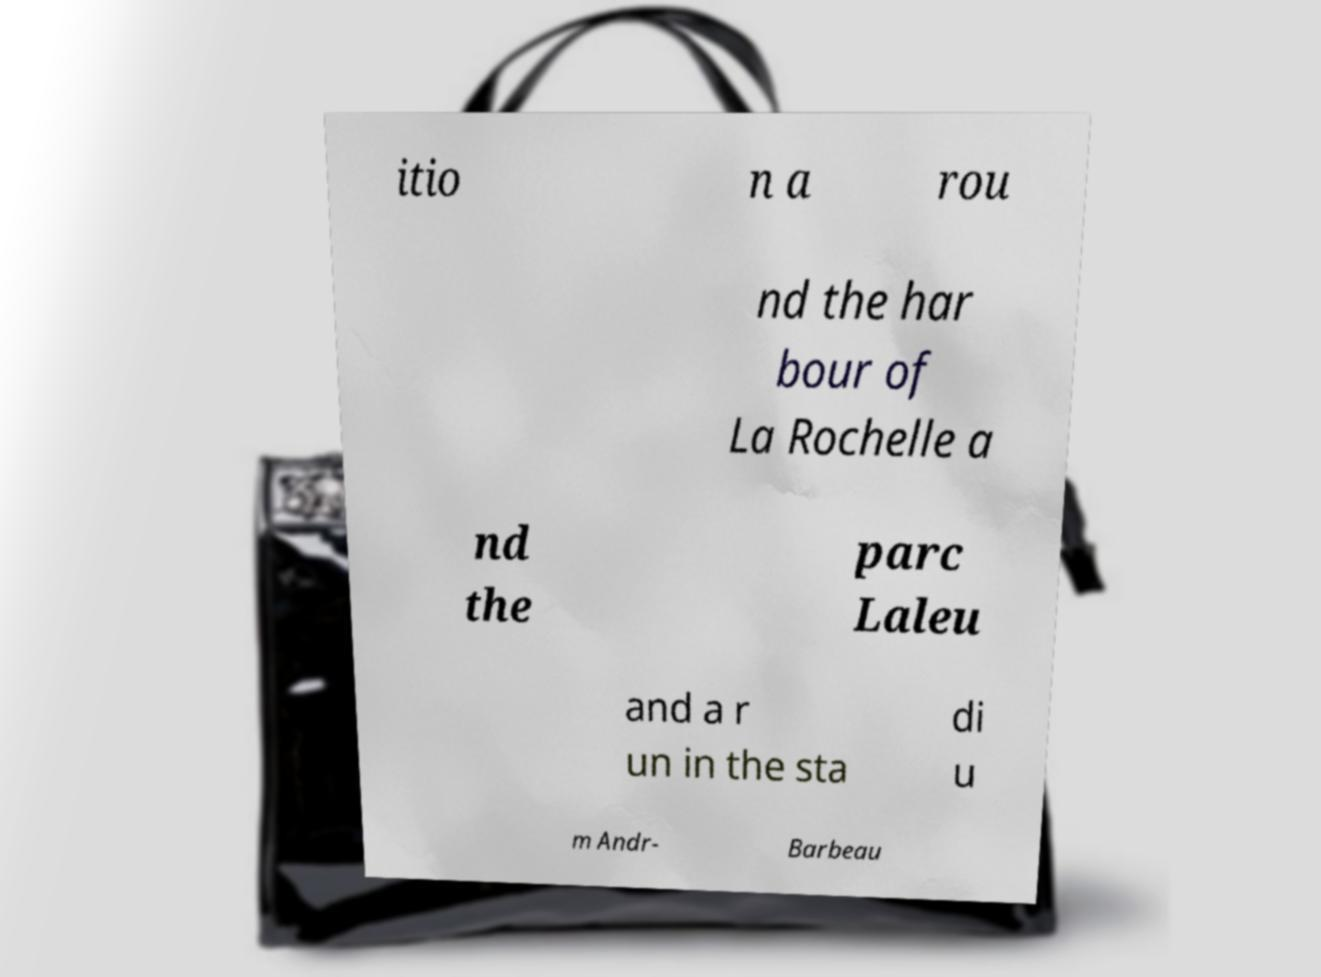Please identify and transcribe the text found in this image. itio n a rou nd the har bour of La Rochelle a nd the parc Laleu and a r un in the sta di u m Andr- Barbeau 